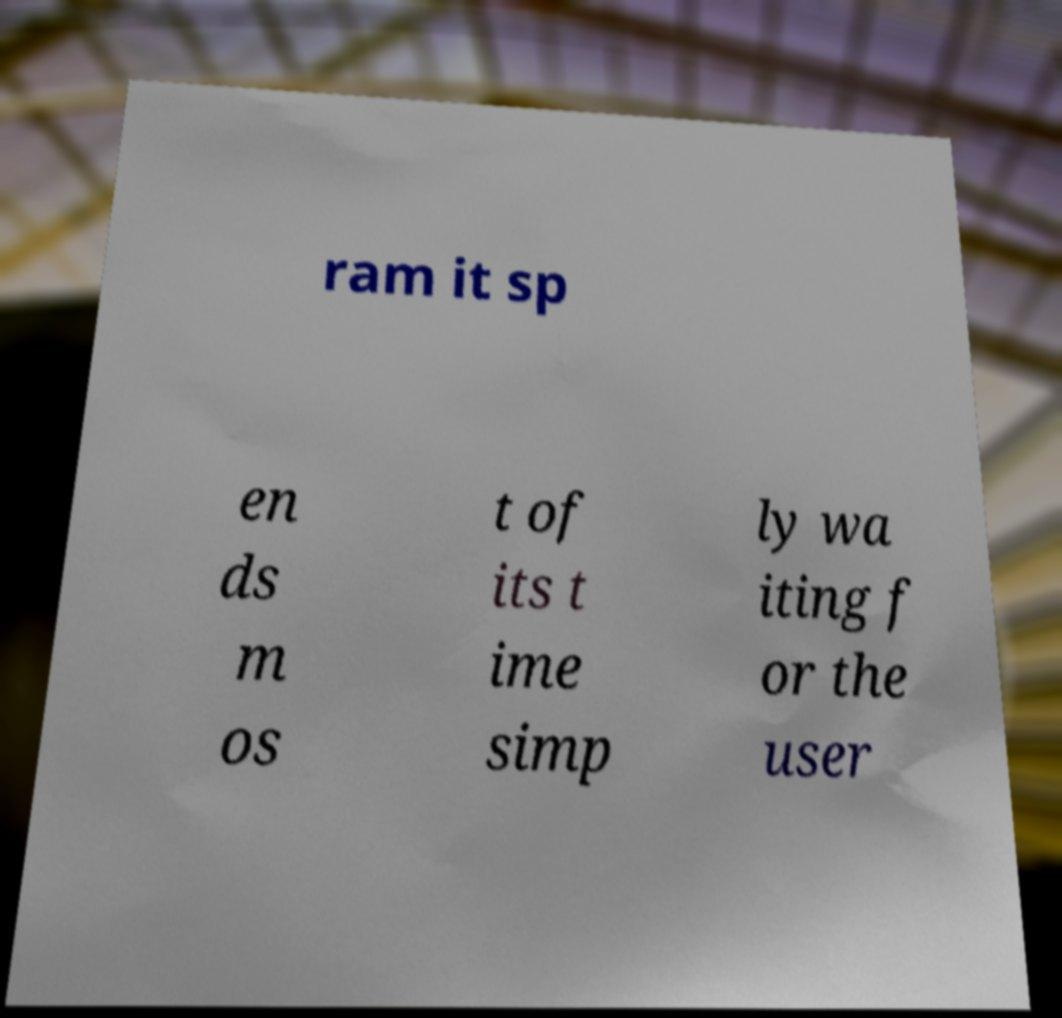Please read and relay the text visible in this image. What does it say? ram it sp en ds m os t of its t ime simp ly wa iting f or the user 